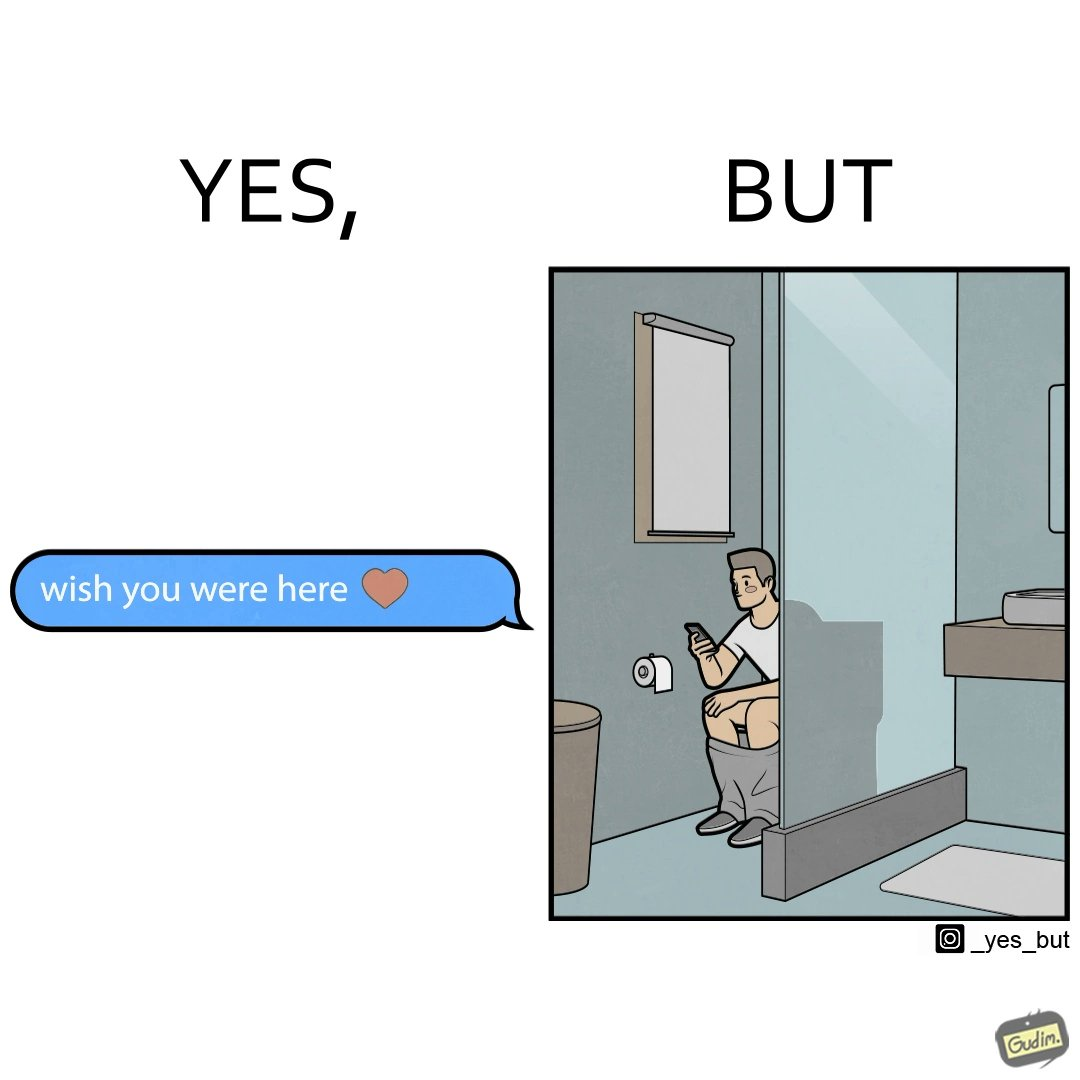Describe the content of this image. The images are funny since it shows how even though a man writes to his partner that he wishes she was there to show that he misses her, it would be inappropriate and gross if it were to happen literally as he is sitting on his toilet 